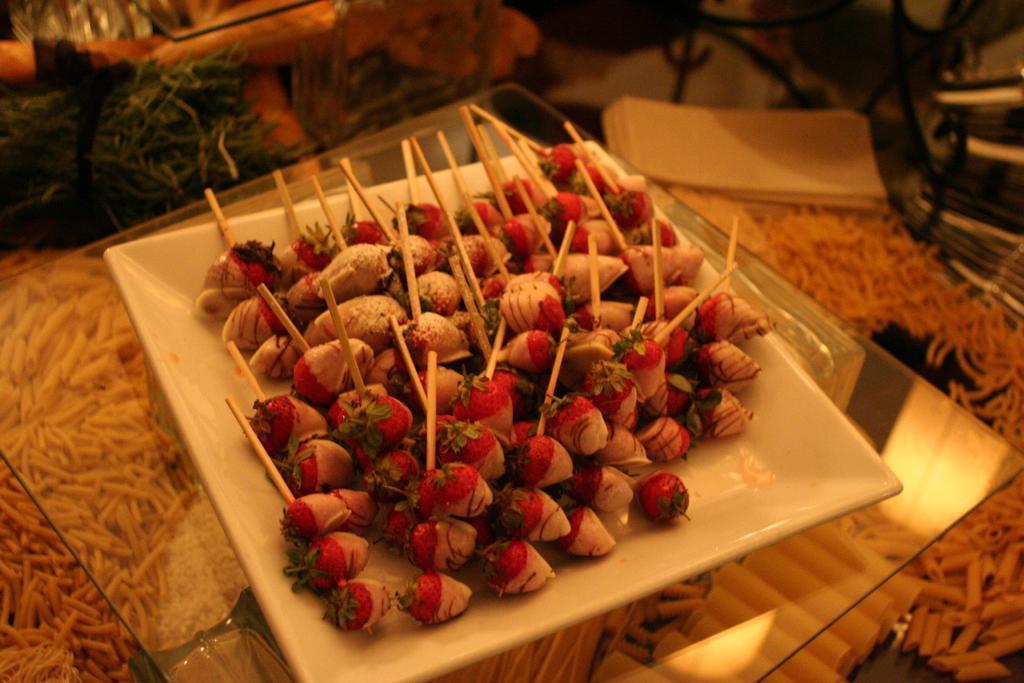Please provide a concise description of this image. This is the plate, which is placed on the glass table. I think this is the carpet. This plate contains strawberries with toothpicks. 